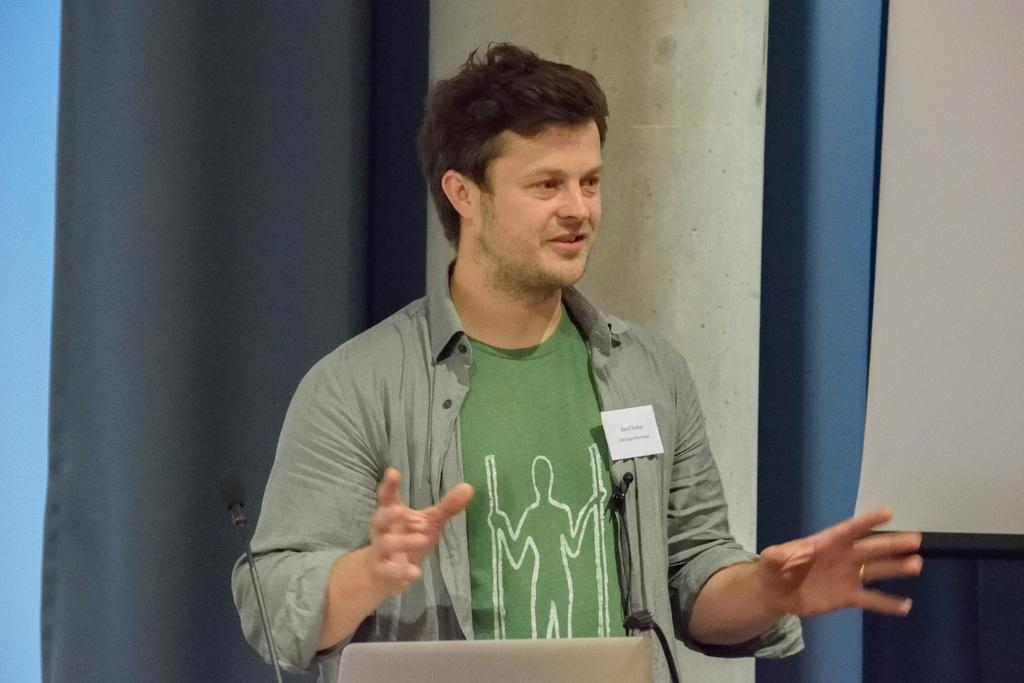Who is the main subject in the image? There is a man in the center of the image. What is the man doing in the image? The man is talking in the image. What objects are in front of the man? There are microphones in front of the man. What can be seen in the background of the image? There is a curtain and a wall in the background of the image. Can you see a pig on stage in the image? There is no pig or stage present in the image. What type of net is being used by the man in the image? The man is not using a net in the image; he is talking with microphones in front of him. 